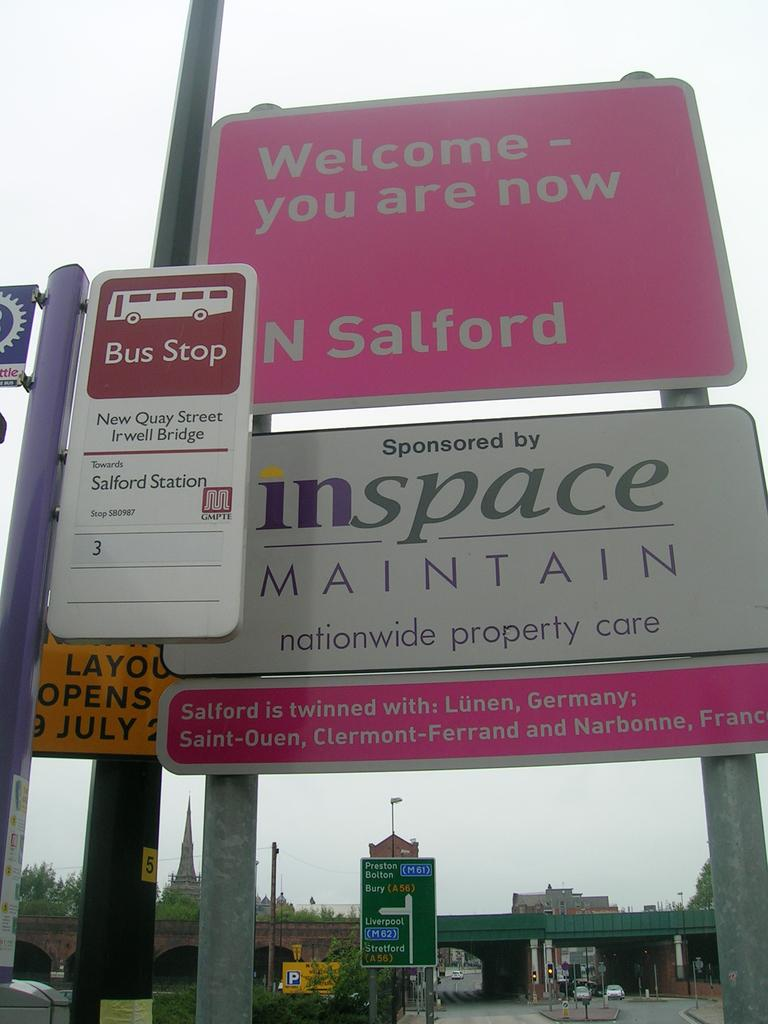Provide a one-sentence caption for the provided image. The sign for Salford is sponsored by inspace. 